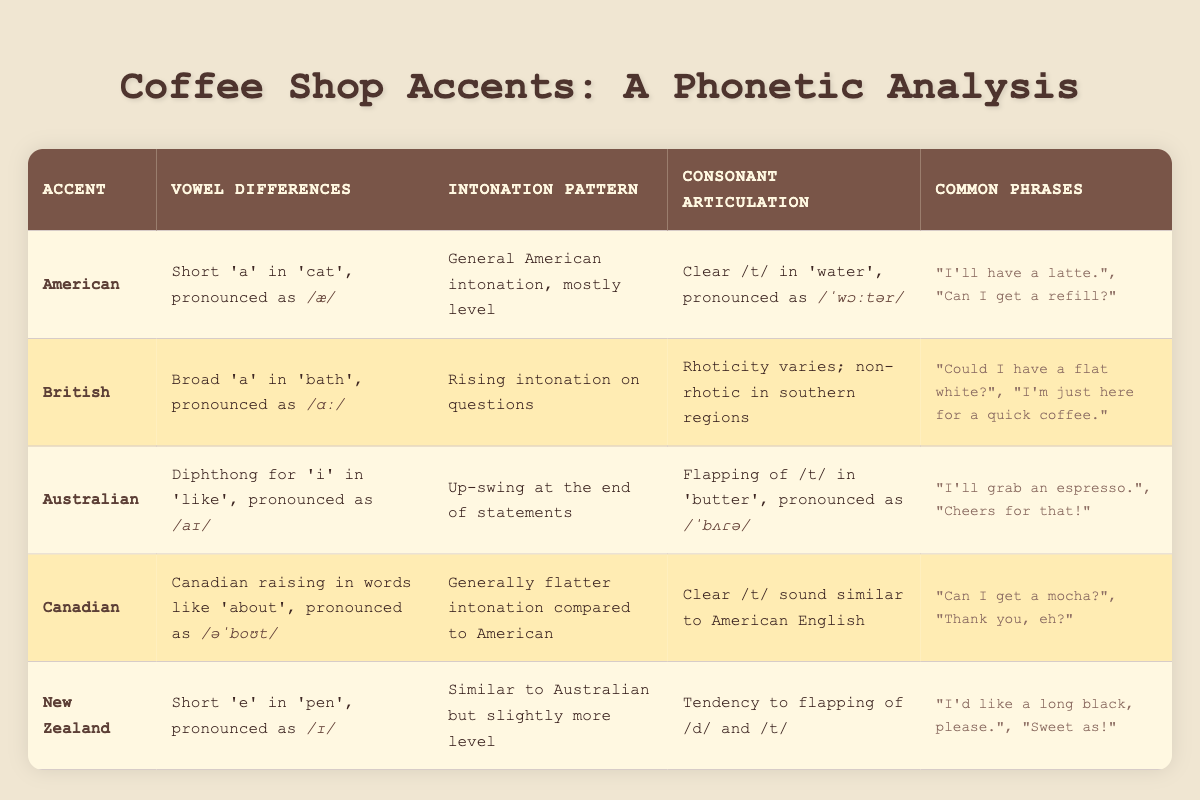What is the vowel difference in the American accent? The table specifically states that the vowel difference in the American accent is described as a short 'a' in 'cat', pronounced as /æ/.
Answer: Short 'a' in 'cat', pronounced as /æ/ Which accent features rising intonation on questions? The table indicates that the British accent has a characteristic of rising intonation on questions, as specified in the corresponding column.
Answer: British accent Are Canadian accents non-rhotic like British accents? By reviewing the table, the Canadian accent is described as having a clear /t/ sound similar to American English, suggesting it is not non-rhotic like some British accents.
Answer: No How many accents have a flapping of /t/? The table lists the Australian and New Zealand accents as having a flapping in their consonant articulation. Therefore, two accents exhibit this feature.
Answer: 2 In which accent is the diphthong for 'i' pronounced as /aɪ/? Consulting the table, the Australian accent is highlighted for having a diphthong for 'i' in 'like', pronounced as /aɪ/.
Answer: Australian accent What are the common phrases associated with the Canadian accent? The table specifies that common phrases for the Canadian accent include "Can I get a mocha?" and "Thank you, eh?".
Answer: "Can I get a mocha?", "Thank you, eh?" Which accent has a vowel difference pronounced as /ɪ/ and how is this reflected in common expressions? The New Zealand accent has a vowel difference pronounced as /ɪ/, noted in the table; common phrases include "I'd like a long black, please." and "Sweet as!", which indicate its pronunciation style.
Answer: New Zealand accent; "I'd like a long black, please.", "Sweet as!" Is the consonant articulation of the American accent similar to the Canadian accent? The table shows that both the American and Canadian accents have a clear /t/ sound, which suggests they share similarities in consonant articulation.
Answer: Yes 